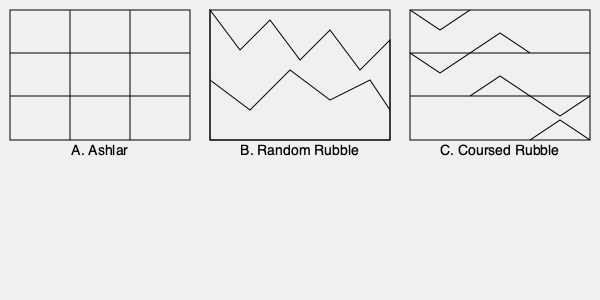As a heritage conservation activist in Wheaton, Illinois, you're assessing a historic building's masonry. Which of the stone masonry patterns shown above would be most resistant to water penetration and structural instability? To determine which stone masonry pattern is most resistant to water penetration and structural instability, let's analyze each pattern:

1. Ashlar (Pattern A):
   - Consists of precisely cut and fitted rectangular stones
   - Minimal gaps between stones
   - Uniform appearance and structure

2. Random Rubble (Pattern B):
   - Irregular stones of various sizes and shapes
   - More gaps and potential weak points
   - Less uniform structure

3. Coursed Rubble (Pattern C):
   - Combination of roughly squared stones laid in courses
   - More regular than random rubble, but less precise than ashlar
   - Some uniformity in structure, but still with irregular stones

Ashlar masonry (Pattern A) offers the best resistance to water penetration and structural instability for the following reasons:

1. Tight Joints: The precisely cut stones fit together with minimal gaps, reducing water infiltration.
2. Even Distribution of Load: The uniform shape and size of stones distribute structural loads evenly.
3. Fewer Weak Points: The regular pattern minimizes potential weak spots in the structure.
4. Durability: The precise fitting of stones reduces the likelihood of individual stones shifting or falling out over time.

While coursed rubble offers some advantages over random rubble, it still has more potential weak points and gaps compared to ashlar masonry. Random rubble, with its irregular pattern and numerous gaps, is the least resistant to water penetration and structural instability among the three options.
Answer: Ashlar (Pattern A) 